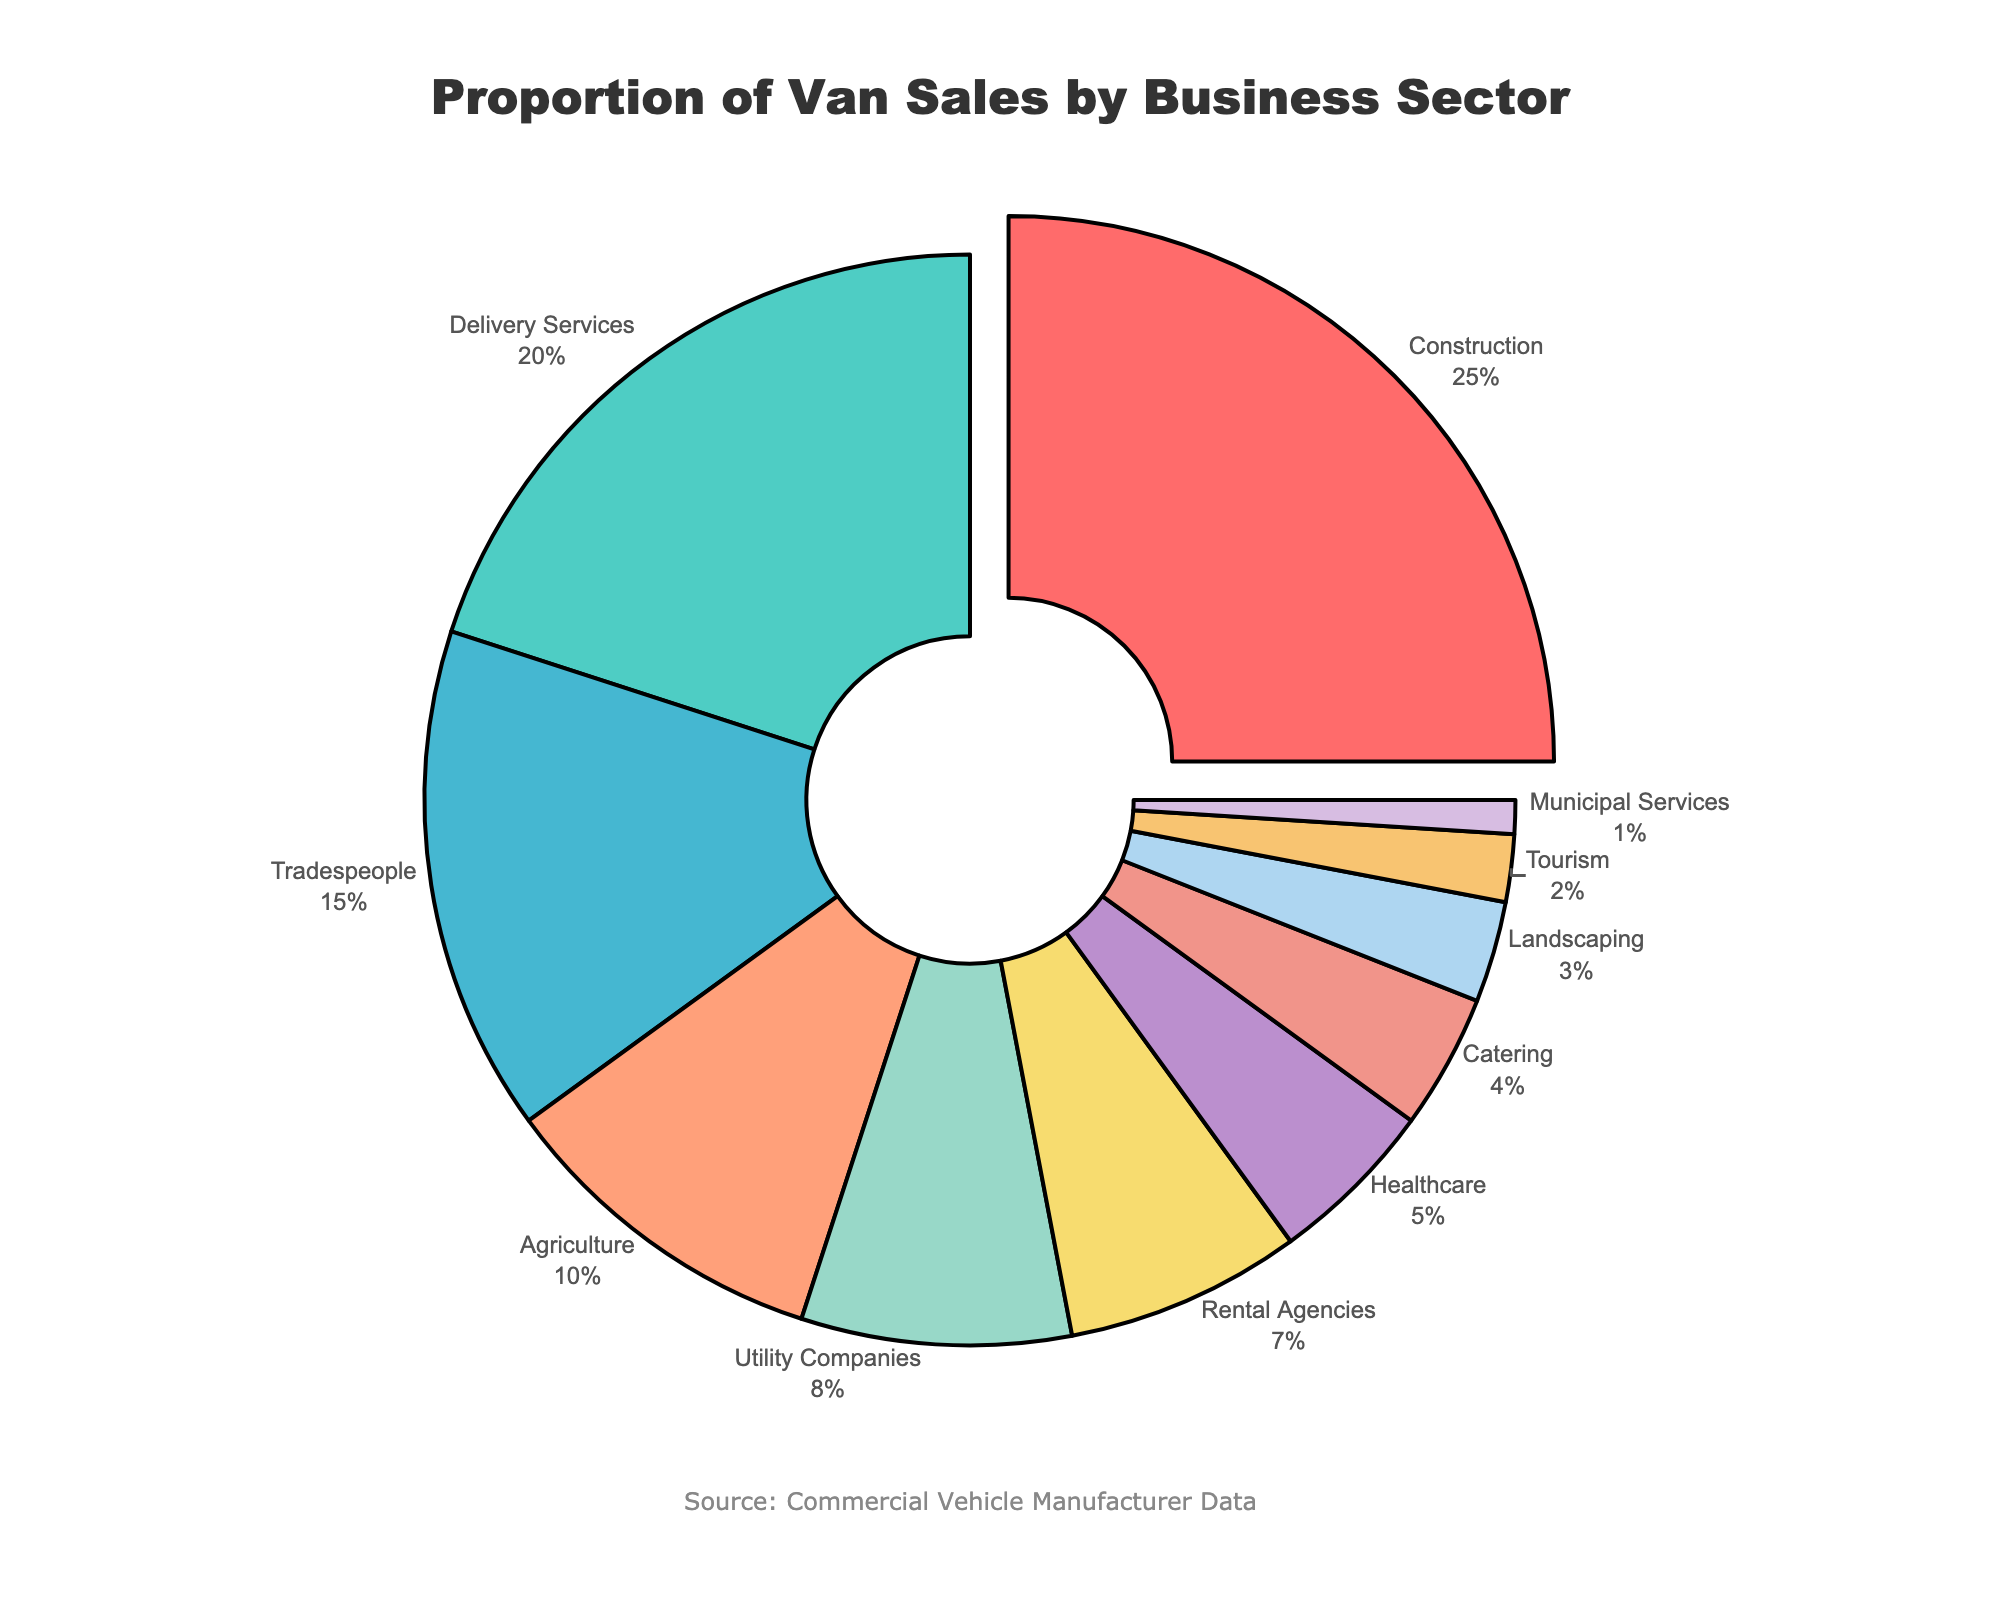What sector has the highest proportion of van sales? In the pie chart, the 'Construction' sector has the largest segment, pulled out from the center for emphasis. Its percentage is also displayed as 25%.
Answer: Construction Which two sectors have the closest proportions of van sales? By examining the segments' sizes and percentages, the 'Catering' and 'Landscaping' sectors have close proportions, with 4% and 3% respectively.
Answer: Catering and Landscaping What is the combined proportion of van sales for the 'Healthcare' and 'Catering' sectors? The pie chart shows 'Healthcare' at 5% and 'Catering' at 4%. Adding these percentages gives 5% + 4% = 9%.
Answer: 9% Is the proportion of van sales in the 'Delivery Services' sector greater than that in the 'Tradespeople' sector? The 'Delivery Services' sector has a proportion of 20%, while the 'Tradespeople' sector has 15%. Since 20% is greater than 15%, the proportion for 'Delivery Services' is indeed greater.
Answer: Yes Which sector has a higher proportion of van sales: 'Utility Companies' or 'Rental Agencies'? 'Utility Companies' have a proportion of 8%, while 'Rental Agencies' have a proportion of 7%. Comparing these values shows that 'Utility Companies' have a higher proportion.
Answer: Utility Companies What is the total proportion of van sales for sectors related to agriculture, utilities, and tourism combined? The proportions for 'Agriculture', 'Utility Companies', and 'Tourism' are 10%, 8%, and 2% respectively. Summing these values gives 10% + 8% + 2% = 20%.
Answer: 20% Which color represents the 'Delivery Services' sector in the pie chart? By matching the 'Delivery Services' label at 20% with its color segment in the chart, it's identified as the teal or light blue segment.
Answer: Teal or Light Blue What is the difference in van sales proportion between 'Tradespeople' and 'Municipal Services'? 'Tradespeople' have a proportion of 15% and 'Municipal Services' have 1%. The difference is calculated as 15% - 1% = 14%.
Answer: 14% Among 'Construction', 'Delivery Services', and 'Tradespeople', which sector has the smallest van sales proportion? In the pie chart, 'Construction' has 25%, 'Delivery Services' has 20%, and 'Tradespeople' has 15%. The smallest proportion among these is 15% for 'Tradespeople'.
Answer: Tradespeople 